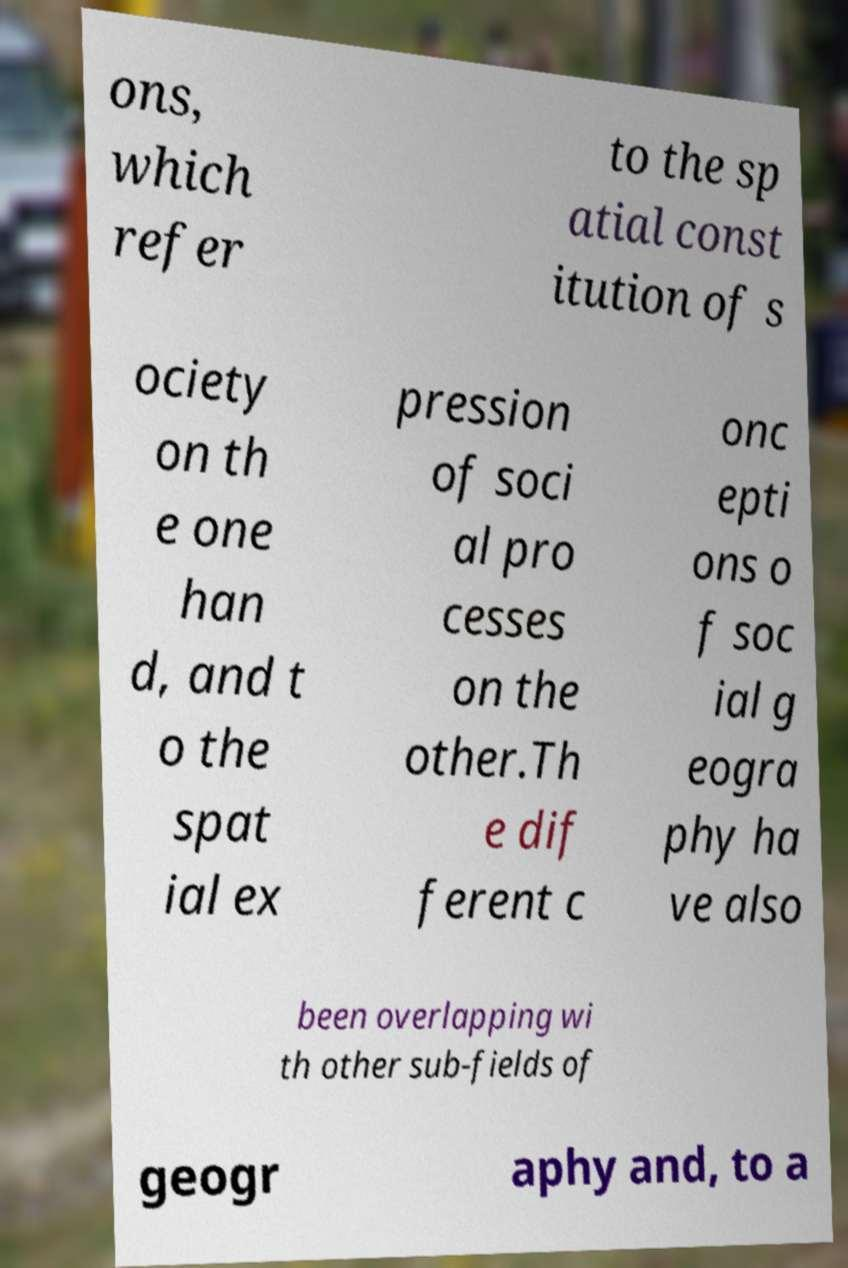Could you extract and type out the text from this image? ons, which refer to the sp atial const itution of s ociety on th e one han d, and t o the spat ial ex pression of soci al pro cesses on the other.Th e dif ferent c onc epti ons o f soc ial g eogra phy ha ve also been overlapping wi th other sub-fields of geogr aphy and, to a 